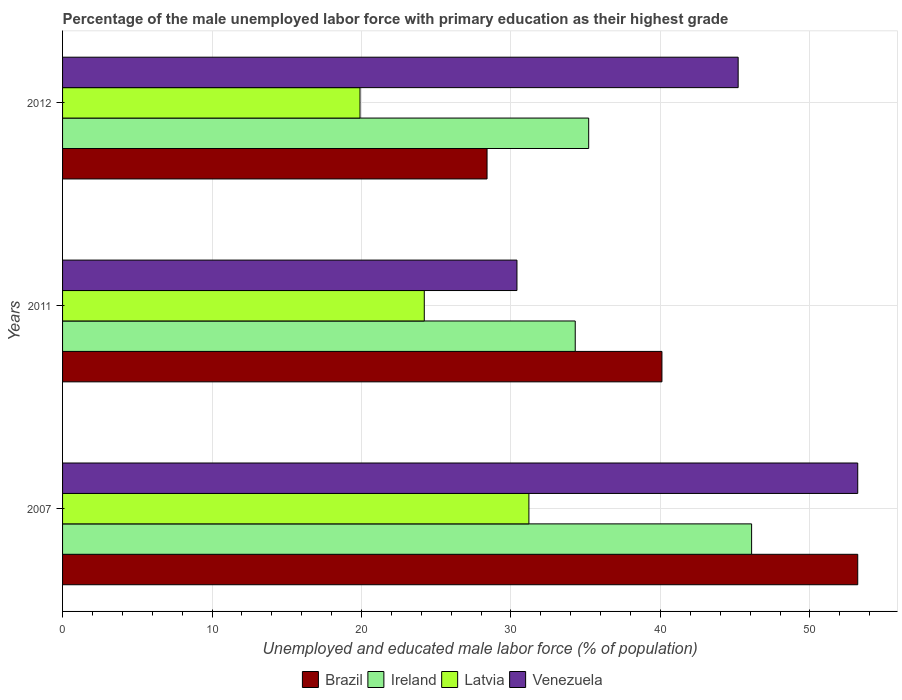How many different coloured bars are there?
Keep it short and to the point. 4. Are the number of bars per tick equal to the number of legend labels?
Keep it short and to the point. Yes. Are the number of bars on each tick of the Y-axis equal?
Offer a very short reply. Yes. How many bars are there on the 3rd tick from the top?
Offer a very short reply. 4. What is the label of the 1st group of bars from the top?
Offer a terse response. 2012. What is the percentage of the unemployed male labor force with primary education in Latvia in 2007?
Offer a terse response. 31.2. Across all years, what is the maximum percentage of the unemployed male labor force with primary education in Venezuela?
Provide a short and direct response. 53.2. Across all years, what is the minimum percentage of the unemployed male labor force with primary education in Brazil?
Provide a short and direct response. 28.4. What is the total percentage of the unemployed male labor force with primary education in Brazil in the graph?
Give a very brief answer. 121.7. What is the difference between the percentage of the unemployed male labor force with primary education in Venezuela in 2011 and that in 2012?
Make the answer very short. -14.8. What is the difference between the percentage of the unemployed male labor force with primary education in Latvia in 2011 and the percentage of the unemployed male labor force with primary education in Ireland in 2012?
Your answer should be very brief. -11. What is the average percentage of the unemployed male labor force with primary education in Latvia per year?
Provide a succinct answer. 25.1. In the year 2007, what is the difference between the percentage of the unemployed male labor force with primary education in Latvia and percentage of the unemployed male labor force with primary education in Brazil?
Give a very brief answer. -22. What is the ratio of the percentage of the unemployed male labor force with primary education in Latvia in 2007 to that in 2011?
Offer a terse response. 1.29. What is the difference between the highest and the second highest percentage of the unemployed male labor force with primary education in Ireland?
Ensure brevity in your answer.  10.9. What is the difference between the highest and the lowest percentage of the unemployed male labor force with primary education in Ireland?
Provide a succinct answer. 11.8. Is the sum of the percentage of the unemployed male labor force with primary education in Ireland in 2007 and 2011 greater than the maximum percentage of the unemployed male labor force with primary education in Brazil across all years?
Your answer should be very brief. Yes. Is it the case that in every year, the sum of the percentage of the unemployed male labor force with primary education in Latvia and percentage of the unemployed male labor force with primary education in Venezuela is greater than the sum of percentage of the unemployed male labor force with primary education in Ireland and percentage of the unemployed male labor force with primary education in Brazil?
Offer a very short reply. No. What does the 3rd bar from the bottom in 2007 represents?
Offer a very short reply. Latvia. Is it the case that in every year, the sum of the percentage of the unemployed male labor force with primary education in Latvia and percentage of the unemployed male labor force with primary education in Venezuela is greater than the percentage of the unemployed male labor force with primary education in Brazil?
Your answer should be very brief. Yes. Are all the bars in the graph horizontal?
Your answer should be very brief. Yes. Does the graph contain any zero values?
Your answer should be very brief. No. Does the graph contain grids?
Make the answer very short. Yes. How many legend labels are there?
Offer a very short reply. 4. What is the title of the graph?
Your answer should be compact. Percentage of the male unemployed labor force with primary education as their highest grade. Does "Cyprus" appear as one of the legend labels in the graph?
Keep it short and to the point. No. What is the label or title of the X-axis?
Make the answer very short. Unemployed and educated male labor force (% of population). What is the label or title of the Y-axis?
Your answer should be very brief. Years. What is the Unemployed and educated male labor force (% of population) in Brazil in 2007?
Your response must be concise. 53.2. What is the Unemployed and educated male labor force (% of population) of Ireland in 2007?
Offer a very short reply. 46.1. What is the Unemployed and educated male labor force (% of population) in Latvia in 2007?
Provide a short and direct response. 31.2. What is the Unemployed and educated male labor force (% of population) of Venezuela in 2007?
Provide a short and direct response. 53.2. What is the Unemployed and educated male labor force (% of population) of Brazil in 2011?
Offer a very short reply. 40.1. What is the Unemployed and educated male labor force (% of population) of Ireland in 2011?
Provide a short and direct response. 34.3. What is the Unemployed and educated male labor force (% of population) of Latvia in 2011?
Offer a very short reply. 24.2. What is the Unemployed and educated male labor force (% of population) of Venezuela in 2011?
Your response must be concise. 30.4. What is the Unemployed and educated male labor force (% of population) in Brazil in 2012?
Give a very brief answer. 28.4. What is the Unemployed and educated male labor force (% of population) of Ireland in 2012?
Keep it short and to the point. 35.2. What is the Unemployed and educated male labor force (% of population) in Latvia in 2012?
Your answer should be compact. 19.9. What is the Unemployed and educated male labor force (% of population) in Venezuela in 2012?
Your answer should be very brief. 45.2. Across all years, what is the maximum Unemployed and educated male labor force (% of population) of Brazil?
Provide a short and direct response. 53.2. Across all years, what is the maximum Unemployed and educated male labor force (% of population) in Ireland?
Give a very brief answer. 46.1. Across all years, what is the maximum Unemployed and educated male labor force (% of population) in Latvia?
Your answer should be very brief. 31.2. Across all years, what is the maximum Unemployed and educated male labor force (% of population) of Venezuela?
Provide a succinct answer. 53.2. Across all years, what is the minimum Unemployed and educated male labor force (% of population) in Brazil?
Keep it short and to the point. 28.4. Across all years, what is the minimum Unemployed and educated male labor force (% of population) of Ireland?
Your answer should be compact. 34.3. Across all years, what is the minimum Unemployed and educated male labor force (% of population) in Latvia?
Give a very brief answer. 19.9. Across all years, what is the minimum Unemployed and educated male labor force (% of population) in Venezuela?
Provide a short and direct response. 30.4. What is the total Unemployed and educated male labor force (% of population) in Brazil in the graph?
Ensure brevity in your answer.  121.7. What is the total Unemployed and educated male labor force (% of population) in Ireland in the graph?
Give a very brief answer. 115.6. What is the total Unemployed and educated male labor force (% of population) of Latvia in the graph?
Offer a very short reply. 75.3. What is the total Unemployed and educated male labor force (% of population) of Venezuela in the graph?
Keep it short and to the point. 128.8. What is the difference between the Unemployed and educated male labor force (% of population) in Brazil in 2007 and that in 2011?
Keep it short and to the point. 13.1. What is the difference between the Unemployed and educated male labor force (% of population) of Venezuela in 2007 and that in 2011?
Your answer should be very brief. 22.8. What is the difference between the Unemployed and educated male labor force (% of population) of Brazil in 2007 and that in 2012?
Keep it short and to the point. 24.8. What is the difference between the Unemployed and educated male labor force (% of population) of Ireland in 2007 and that in 2012?
Make the answer very short. 10.9. What is the difference between the Unemployed and educated male labor force (% of population) of Venezuela in 2011 and that in 2012?
Provide a short and direct response. -14.8. What is the difference between the Unemployed and educated male labor force (% of population) of Brazil in 2007 and the Unemployed and educated male labor force (% of population) of Ireland in 2011?
Ensure brevity in your answer.  18.9. What is the difference between the Unemployed and educated male labor force (% of population) in Brazil in 2007 and the Unemployed and educated male labor force (% of population) in Latvia in 2011?
Offer a very short reply. 29. What is the difference between the Unemployed and educated male labor force (% of population) in Brazil in 2007 and the Unemployed and educated male labor force (% of population) in Venezuela in 2011?
Ensure brevity in your answer.  22.8. What is the difference between the Unemployed and educated male labor force (% of population) of Ireland in 2007 and the Unemployed and educated male labor force (% of population) of Latvia in 2011?
Offer a very short reply. 21.9. What is the difference between the Unemployed and educated male labor force (% of population) in Brazil in 2007 and the Unemployed and educated male labor force (% of population) in Ireland in 2012?
Keep it short and to the point. 18. What is the difference between the Unemployed and educated male labor force (% of population) of Brazil in 2007 and the Unemployed and educated male labor force (% of population) of Latvia in 2012?
Keep it short and to the point. 33.3. What is the difference between the Unemployed and educated male labor force (% of population) in Brazil in 2007 and the Unemployed and educated male labor force (% of population) in Venezuela in 2012?
Provide a short and direct response. 8. What is the difference between the Unemployed and educated male labor force (% of population) of Ireland in 2007 and the Unemployed and educated male labor force (% of population) of Latvia in 2012?
Your answer should be compact. 26.2. What is the difference between the Unemployed and educated male labor force (% of population) of Ireland in 2007 and the Unemployed and educated male labor force (% of population) of Venezuela in 2012?
Offer a very short reply. 0.9. What is the difference between the Unemployed and educated male labor force (% of population) in Latvia in 2007 and the Unemployed and educated male labor force (% of population) in Venezuela in 2012?
Your response must be concise. -14. What is the difference between the Unemployed and educated male labor force (% of population) in Brazil in 2011 and the Unemployed and educated male labor force (% of population) in Latvia in 2012?
Provide a short and direct response. 20.2. What is the difference between the Unemployed and educated male labor force (% of population) in Brazil in 2011 and the Unemployed and educated male labor force (% of population) in Venezuela in 2012?
Ensure brevity in your answer.  -5.1. What is the difference between the Unemployed and educated male labor force (% of population) in Ireland in 2011 and the Unemployed and educated male labor force (% of population) in Latvia in 2012?
Give a very brief answer. 14.4. What is the difference between the Unemployed and educated male labor force (% of population) in Latvia in 2011 and the Unemployed and educated male labor force (% of population) in Venezuela in 2012?
Your response must be concise. -21. What is the average Unemployed and educated male labor force (% of population) of Brazil per year?
Make the answer very short. 40.57. What is the average Unemployed and educated male labor force (% of population) of Ireland per year?
Give a very brief answer. 38.53. What is the average Unemployed and educated male labor force (% of population) of Latvia per year?
Your response must be concise. 25.1. What is the average Unemployed and educated male labor force (% of population) of Venezuela per year?
Give a very brief answer. 42.93. In the year 2007, what is the difference between the Unemployed and educated male labor force (% of population) of Brazil and Unemployed and educated male labor force (% of population) of Ireland?
Provide a short and direct response. 7.1. In the year 2007, what is the difference between the Unemployed and educated male labor force (% of population) of Brazil and Unemployed and educated male labor force (% of population) of Venezuela?
Your answer should be very brief. 0. In the year 2011, what is the difference between the Unemployed and educated male labor force (% of population) of Ireland and Unemployed and educated male labor force (% of population) of Venezuela?
Make the answer very short. 3.9. In the year 2011, what is the difference between the Unemployed and educated male labor force (% of population) in Latvia and Unemployed and educated male labor force (% of population) in Venezuela?
Make the answer very short. -6.2. In the year 2012, what is the difference between the Unemployed and educated male labor force (% of population) in Brazil and Unemployed and educated male labor force (% of population) in Venezuela?
Your answer should be compact. -16.8. In the year 2012, what is the difference between the Unemployed and educated male labor force (% of population) in Ireland and Unemployed and educated male labor force (% of population) in Venezuela?
Offer a terse response. -10. In the year 2012, what is the difference between the Unemployed and educated male labor force (% of population) in Latvia and Unemployed and educated male labor force (% of population) in Venezuela?
Provide a succinct answer. -25.3. What is the ratio of the Unemployed and educated male labor force (% of population) of Brazil in 2007 to that in 2011?
Your answer should be very brief. 1.33. What is the ratio of the Unemployed and educated male labor force (% of population) in Ireland in 2007 to that in 2011?
Provide a short and direct response. 1.34. What is the ratio of the Unemployed and educated male labor force (% of population) of Latvia in 2007 to that in 2011?
Make the answer very short. 1.29. What is the ratio of the Unemployed and educated male labor force (% of population) in Venezuela in 2007 to that in 2011?
Provide a short and direct response. 1.75. What is the ratio of the Unemployed and educated male labor force (% of population) of Brazil in 2007 to that in 2012?
Keep it short and to the point. 1.87. What is the ratio of the Unemployed and educated male labor force (% of population) in Ireland in 2007 to that in 2012?
Offer a very short reply. 1.31. What is the ratio of the Unemployed and educated male labor force (% of population) in Latvia in 2007 to that in 2012?
Your answer should be very brief. 1.57. What is the ratio of the Unemployed and educated male labor force (% of population) of Venezuela in 2007 to that in 2012?
Offer a terse response. 1.18. What is the ratio of the Unemployed and educated male labor force (% of population) in Brazil in 2011 to that in 2012?
Provide a short and direct response. 1.41. What is the ratio of the Unemployed and educated male labor force (% of population) of Ireland in 2011 to that in 2012?
Ensure brevity in your answer.  0.97. What is the ratio of the Unemployed and educated male labor force (% of population) of Latvia in 2011 to that in 2012?
Give a very brief answer. 1.22. What is the ratio of the Unemployed and educated male labor force (% of population) of Venezuela in 2011 to that in 2012?
Keep it short and to the point. 0.67. What is the difference between the highest and the second highest Unemployed and educated male labor force (% of population) in Brazil?
Your answer should be very brief. 13.1. What is the difference between the highest and the second highest Unemployed and educated male labor force (% of population) of Ireland?
Your response must be concise. 10.9. What is the difference between the highest and the lowest Unemployed and educated male labor force (% of population) of Brazil?
Provide a short and direct response. 24.8. What is the difference between the highest and the lowest Unemployed and educated male labor force (% of population) in Ireland?
Your response must be concise. 11.8. What is the difference between the highest and the lowest Unemployed and educated male labor force (% of population) in Venezuela?
Ensure brevity in your answer.  22.8. 